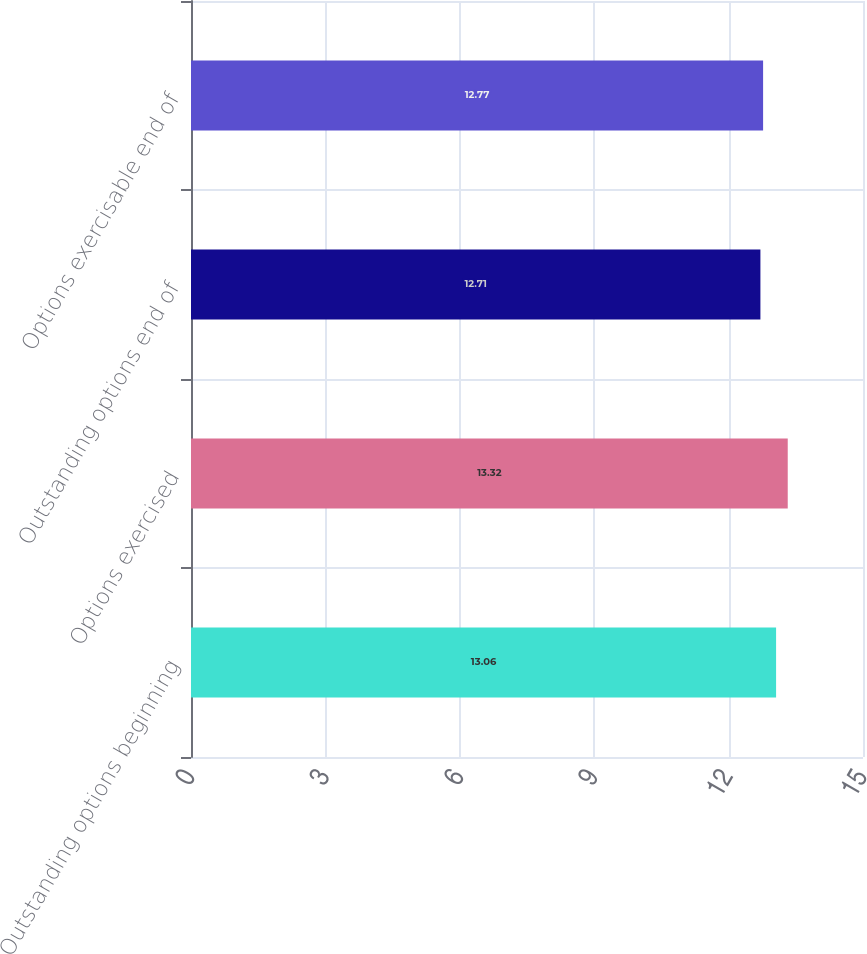Convert chart. <chart><loc_0><loc_0><loc_500><loc_500><bar_chart><fcel>Outstanding options beginning<fcel>Options exercised<fcel>Outstanding options end of<fcel>Options exercisable end of<nl><fcel>13.06<fcel>13.32<fcel>12.71<fcel>12.77<nl></chart> 